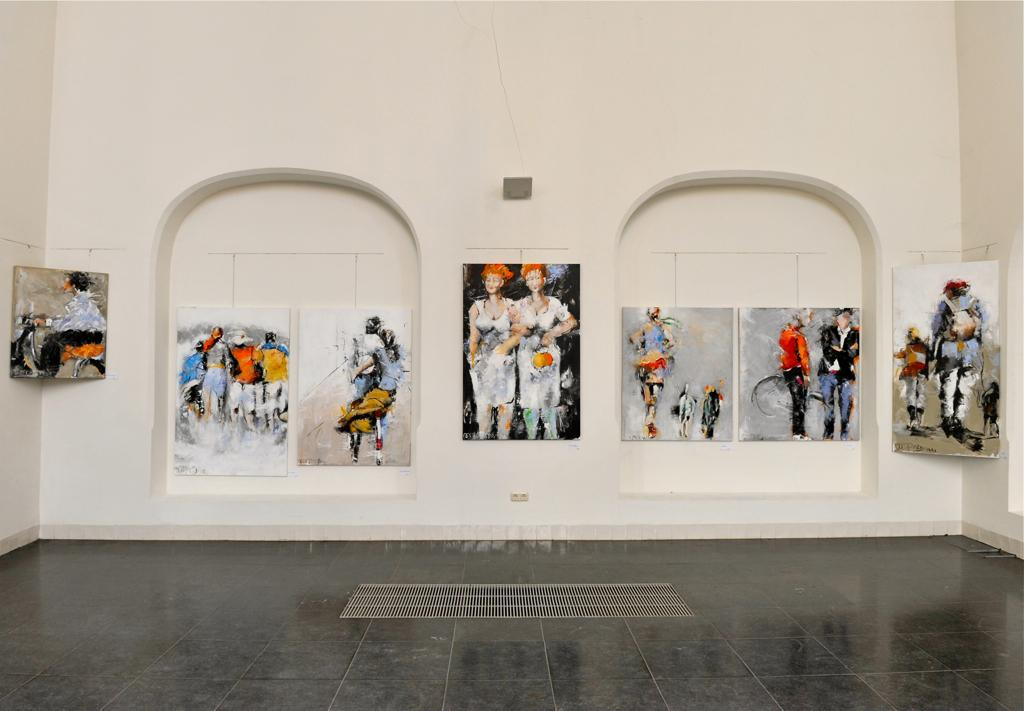What type of artwork is displayed on the wall in the image? There are photo frames of paintings on the wall in the image. What can be seen providing illumination in the image? There is a light visible in the image. What type of electrical outlet is present in the image? There is a power socket in the image. How many toes are visible in the image? There are no toes visible in the image. What type of office furniture is present in the image? There is no office furniture present in the image. 